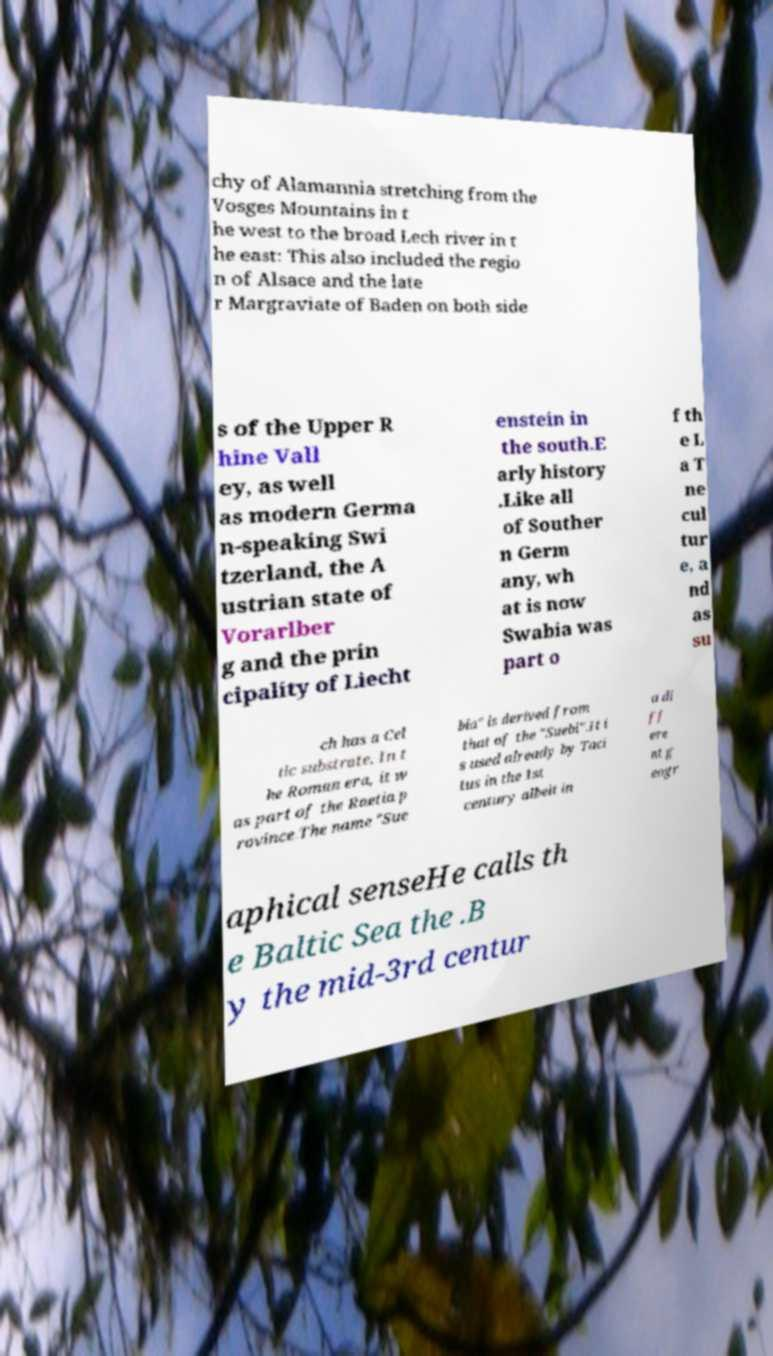There's text embedded in this image that I need extracted. Can you transcribe it verbatim? chy of Alamannia stretching from the Vosges Mountains in t he west to the broad Lech river in t he east: This also included the regio n of Alsace and the late r Margraviate of Baden on both side s of the Upper R hine Vall ey, as well as modern Germa n-speaking Swi tzerland, the A ustrian state of Vorarlber g and the prin cipality of Liecht enstein in the south.E arly history .Like all of Souther n Germ any, wh at is now Swabia was part o f th e L a T ne cul tur e, a nd as su ch has a Cel tic substrate. In t he Roman era, it w as part of the Raetia p rovince.The name "Sue bia" is derived from that of the "Suebi".It i s used already by Taci tus in the 1st century albeit in a di ff ere nt g eogr aphical senseHe calls th e Baltic Sea the .B y the mid-3rd centur 